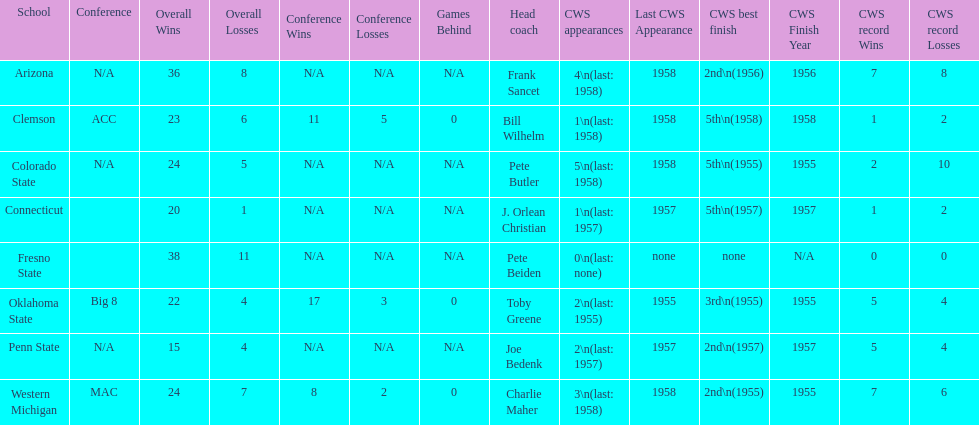Write the full table. {'header': ['School', 'Conference', 'Overall Wins', 'Overall Losses', 'Conference Wins', 'Conference Losses', 'Games Behind', 'Head coach', 'CWS appearances', 'Last CWS Appearance', 'CWS best finish', 'CWS Finish Year', 'CWS record Wins', 'CWS record Losses'], 'rows': [['Arizona', 'N/A', '36', '8', 'N/A', 'N/A', 'N/A', 'Frank Sancet', '4\\n(last: 1958)', '1958', '2nd\\n(1956)', '1956', '7', '8'], ['Clemson', 'ACC', '23', '6', '11', '5', '0', 'Bill Wilhelm', '1\\n(last: 1958)', '1958', '5th\\n(1958)', '1958', '1', '2'], ['Colorado State', 'N/A', '24', '5', 'N/A', 'N/A', 'N/A', 'Pete Butler', '5\\n(last: 1958)', '1958', '5th\\n(1955)', '1955', '2', '10'], ['Connecticut', '', '20', '1', 'N/A', 'N/A', 'N/A', 'J. Orlean Christian', '1\\n(last: 1957)', '1957', '5th\\n(1957)', '1957', '1', '2'], ['Fresno State', '', '38', '11', 'N/A', 'N/A', 'N/A', 'Pete Beiden', '0\\n(last: none)', 'none', 'none', 'N/A', '0', '0'], ['Oklahoma State', 'Big 8', '22', '4', '17', '3', '0', 'Toby Greene', '2\\n(last: 1955)', '1955', '3rd\\n(1955)', '1955', '5', '4'], ['Penn State', 'N/A', '15', '4', 'N/A', 'N/A', 'N/A', 'Joe Bedenk', '2\\n(last: 1957)', '1957', '2nd\\n(1957)', '1957', '5', '4'], ['Western Michigan', 'MAC', '24', '7', '8', '2', '0', 'Charlie Maher', '3\\n(last: 1958)', '1958', '2nd\\n(1955)', '1955', '7', '6']]} What are the number of schools with more than 2 cws appearances? 3. 